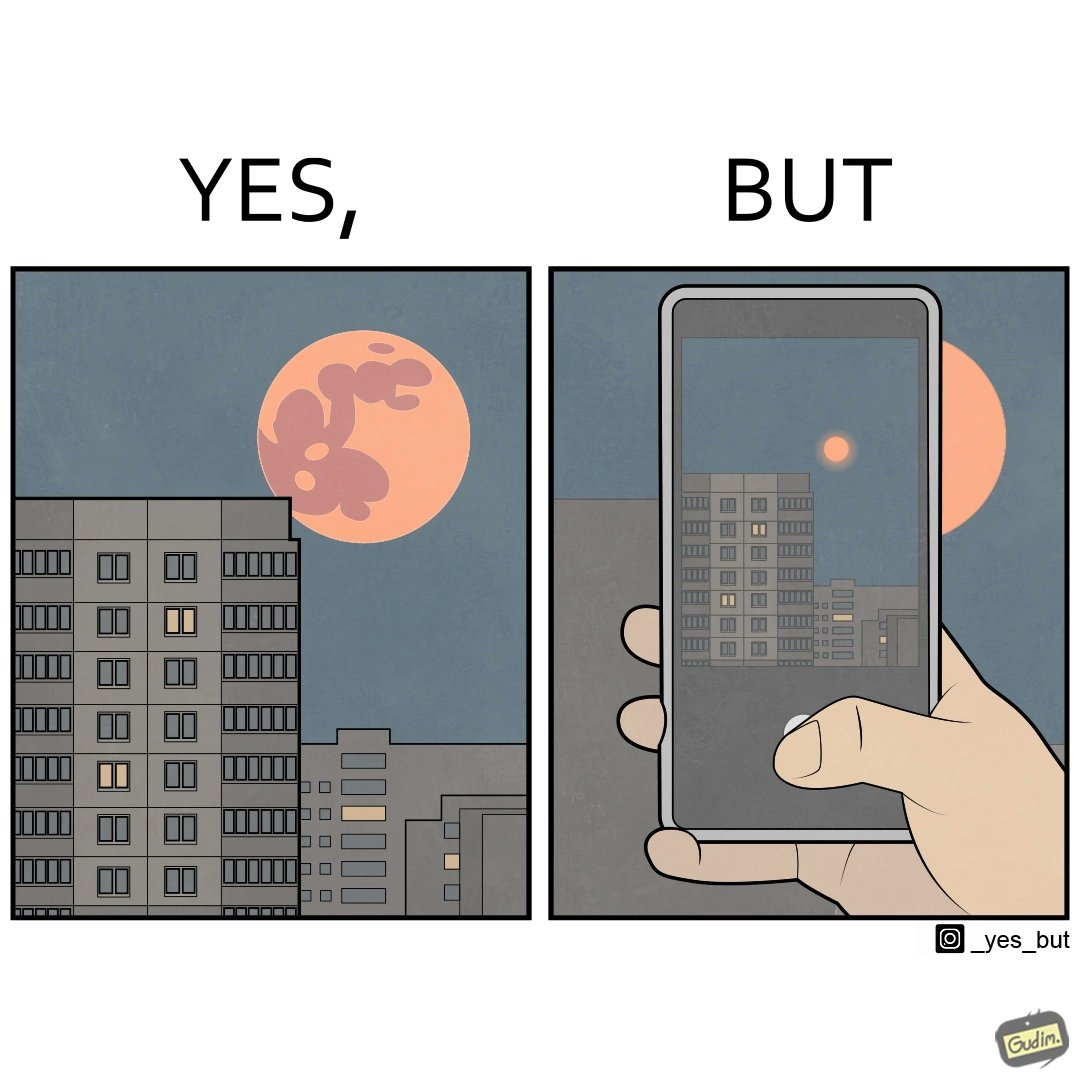Is this image satirical or non-satirical? Yes, this image is satirical. 